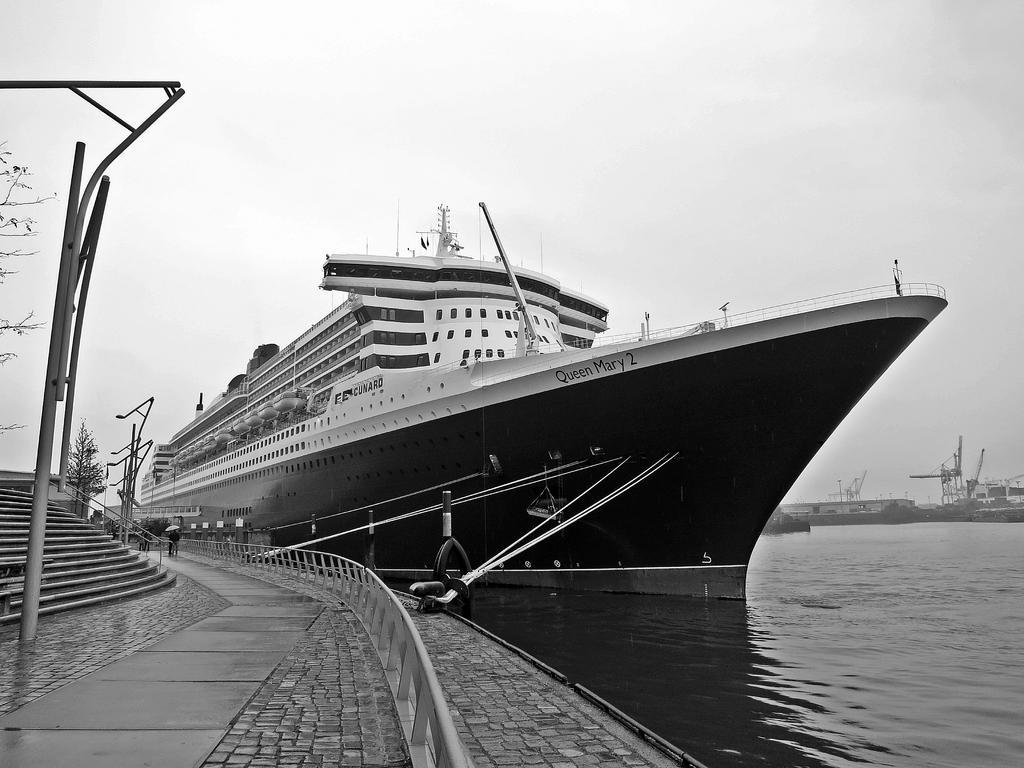Describe this image in one or two sentences. This is a black and white image. I can see a ship and the boats on the water. On the left side of the image, I can see a person standing on the pathway, poles, stairs and a tree. In the background, there is the sky. 